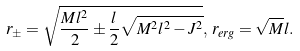<formula> <loc_0><loc_0><loc_500><loc_500>r _ { \pm } = \sqrt { \frac { M l ^ { 2 } } { 2 } \pm \frac { l } { 2 } \sqrt { M ^ { 2 } l ^ { 2 } - J ^ { 2 } } } , \, r _ { e r g } = \sqrt { M } l .</formula> 